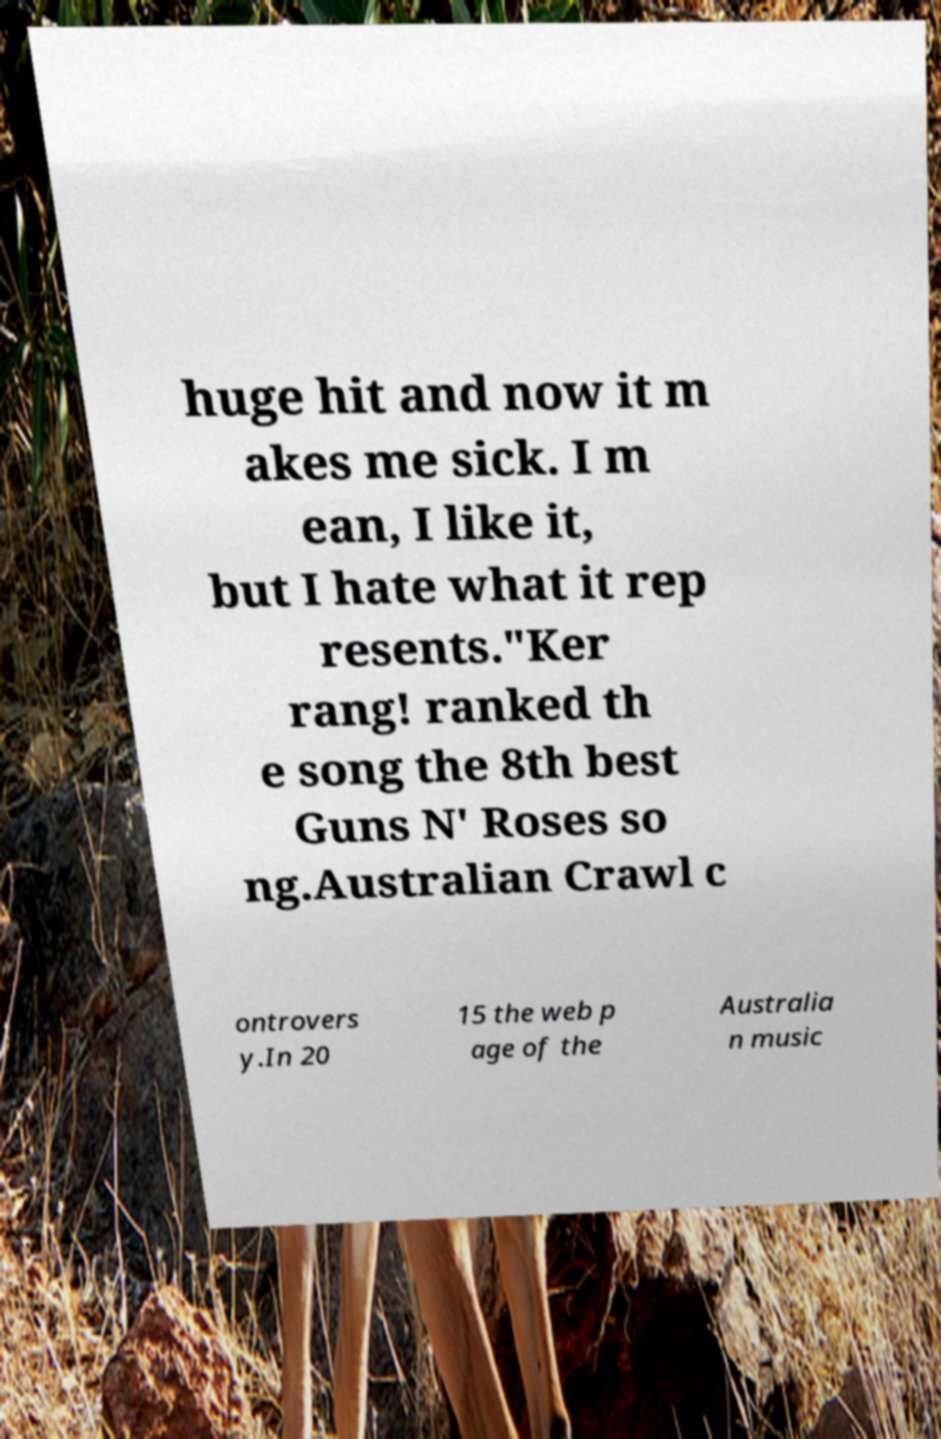I need the written content from this picture converted into text. Can you do that? huge hit and now it m akes me sick. I m ean, I like it, but I hate what it rep resents."Ker rang! ranked th e song the 8th best Guns N' Roses so ng.Australian Crawl c ontrovers y.In 20 15 the web p age of the Australia n music 